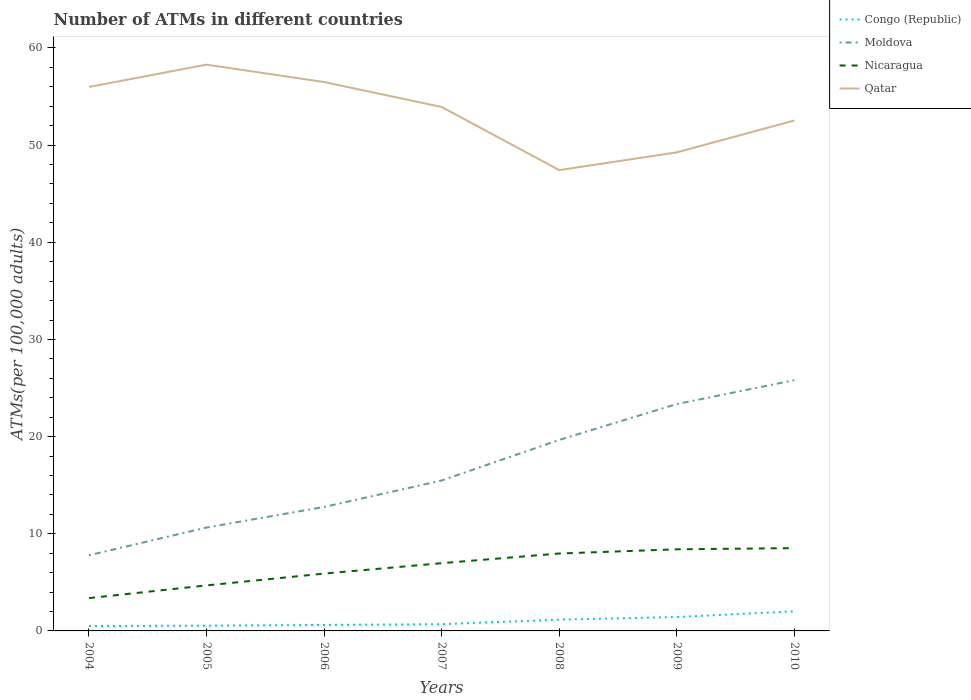How many different coloured lines are there?
Offer a very short reply. 4. Across all years, what is the maximum number of ATMs in Congo (Republic)?
Provide a short and direct response. 0.5. In which year was the number of ATMs in Nicaragua maximum?
Offer a terse response. 2004. What is the total number of ATMs in Qatar in the graph?
Your response must be concise. 5.75. What is the difference between the highest and the second highest number of ATMs in Congo (Republic)?
Give a very brief answer. 1.52. How many lines are there?
Your response must be concise. 4. How many years are there in the graph?
Your answer should be compact. 7. Does the graph contain grids?
Make the answer very short. No. Where does the legend appear in the graph?
Your response must be concise. Top right. How are the legend labels stacked?
Ensure brevity in your answer.  Vertical. What is the title of the graph?
Make the answer very short. Number of ATMs in different countries. Does "Latin America(all income levels)" appear as one of the legend labels in the graph?
Keep it short and to the point. No. What is the label or title of the Y-axis?
Your answer should be compact. ATMs(per 100,0 adults). What is the ATMs(per 100,000 adults) in Congo (Republic) in 2004?
Keep it short and to the point. 0.5. What is the ATMs(per 100,000 adults) of Moldova in 2004?
Provide a short and direct response. 7.79. What is the ATMs(per 100,000 adults) in Nicaragua in 2004?
Provide a short and direct response. 3.38. What is the ATMs(per 100,000 adults) of Qatar in 2004?
Ensure brevity in your answer.  55.99. What is the ATMs(per 100,000 adults) in Congo (Republic) in 2005?
Your response must be concise. 0.54. What is the ATMs(per 100,000 adults) of Moldova in 2005?
Your response must be concise. 10.64. What is the ATMs(per 100,000 adults) of Nicaragua in 2005?
Keep it short and to the point. 4.68. What is the ATMs(per 100,000 adults) of Qatar in 2005?
Your response must be concise. 58.28. What is the ATMs(per 100,000 adults) of Congo (Republic) in 2006?
Your answer should be very brief. 0.62. What is the ATMs(per 100,000 adults) in Moldova in 2006?
Provide a succinct answer. 12.76. What is the ATMs(per 100,000 adults) in Nicaragua in 2006?
Provide a succinct answer. 5.9. What is the ATMs(per 100,000 adults) of Qatar in 2006?
Ensure brevity in your answer.  56.49. What is the ATMs(per 100,000 adults) in Congo (Republic) in 2007?
Offer a terse response. 0.69. What is the ATMs(per 100,000 adults) of Moldova in 2007?
Keep it short and to the point. 15.48. What is the ATMs(per 100,000 adults) of Nicaragua in 2007?
Provide a succinct answer. 6.97. What is the ATMs(per 100,000 adults) of Qatar in 2007?
Give a very brief answer. 53.93. What is the ATMs(per 100,000 adults) of Congo (Republic) in 2008?
Give a very brief answer. 1.16. What is the ATMs(per 100,000 adults) in Moldova in 2008?
Your response must be concise. 19.66. What is the ATMs(per 100,000 adults) of Nicaragua in 2008?
Provide a short and direct response. 7.97. What is the ATMs(per 100,000 adults) in Qatar in 2008?
Ensure brevity in your answer.  47.43. What is the ATMs(per 100,000 adults) in Congo (Republic) in 2009?
Your response must be concise. 1.43. What is the ATMs(per 100,000 adults) in Moldova in 2009?
Your answer should be very brief. 23.35. What is the ATMs(per 100,000 adults) in Nicaragua in 2009?
Your answer should be very brief. 8.4. What is the ATMs(per 100,000 adults) in Qatar in 2009?
Your answer should be compact. 49.25. What is the ATMs(per 100,000 adults) of Congo (Republic) in 2010?
Provide a short and direct response. 2.02. What is the ATMs(per 100,000 adults) of Moldova in 2010?
Provide a short and direct response. 25.81. What is the ATMs(per 100,000 adults) of Nicaragua in 2010?
Offer a terse response. 8.52. What is the ATMs(per 100,000 adults) in Qatar in 2010?
Ensure brevity in your answer.  52.53. Across all years, what is the maximum ATMs(per 100,000 adults) in Congo (Republic)?
Keep it short and to the point. 2.02. Across all years, what is the maximum ATMs(per 100,000 adults) of Moldova?
Offer a terse response. 25.81. Across all years, what is the maximum ATMs(per 100,000 adults) in Nicaragua?
Give a very brief answer. 8.52. Across all years, what is the maximum ATMs(per 100,000 adults) of Qatar?
Provide a succinct answer. 58.28. Across all years, what is the minimum ATMs(per 100,000 adults) in Congo (Republic)?
Keep it short and to the point. 0.5. Across all years, what is the minimum ATMs(per 100,000 adults) in Moldova?
Your answer should be very brief. 7.79. Across all years, what is the minimum ATMs(per 100,000 adults) in Nicaragua?
Your response must be concise. 3.38. Across all years, what is the minimum ATMs(per 100,000 adults) in Qatar?
Keep it short and to the point. 47.43. What is the total ATMs(per 100,000 adults) of Congo (Republic) in the graph?
Offer a very short reply. 6.96. What is the total ATMs(per 100,000 adults) of Moldova in the graph?
Provide a short and direct response. 115.49. What is the total ATMs(per 100,000 adults) of Nicaragua in the graph?
Your response must be concise. 45.82. What is the total ATMs(per 100,000 adults) of Qatar in the graph?
Provide a succinct answer. 373.9. What is the difference between the ATMs(per 100,000 adults) in Congo (Republic) in 2004 and that in 2005?
Provide a short and direct response. -0.04. What is the difference between the ATMs(per 100,000 adults) in Moldova in 2004 and that in 2005?
Give a very brief answer. -2.85. What is the difference between the ATMs(per 100,000 adults) of Nicaragua in 2004 and that in 2005?
Make the answer very short. -1.31. What is the difference between the ATMs(per 100,000 adults) of Qatar in 2004 and that in 2005?
Make the answer very short. -2.3. What is the difference between the ATMs(per 100,000 adults) in Congo (Republic) in 2004 and that in 2006?
Your answer should be compact. -0.12. What is the difference between the ATMs(per 100,000 adults) of Moldova in 2004 and that in 2006?
Ensure brevity in your answer.  -4.97. What is the difference between the ATMs(per 100,000 adults) of Nicaragua in 2004 and that in 2006?
Offer a very short reply. -2.52. What is the difference between the ATMs(per 100,000 adults) in Qatar in 2004 and that in 2006?
Your answer should be compact. -0.51. What is the difference between the ATMs(per 100,000 adults) of Congo (Republic) in 2004 and that in 2007?
Offer a terse response. -0.19. What is the difference between the ATMs(per 100,000 adults) in Moldova in 2004 and that in 2007?
Offer a very short reply. -7.69. What is the difference between the ATMs(per 100,000 adults) in Nicaragua in 2004 and that in 2007?
Give a very brief answer. -3.6. What is the difference between the ATMs(per 100,000 adults) of Qatar in 2004 and that in 2007?
Offer a terse response. 2.06. What is the difference between the ATMs(per 100,000 adults) in Congo (Republic) in 2004 and that in 2008?
Your answer should be compact. -0.66. What is the difference between the ATMs(per 100,000 adults) in Moldova in 2004 and that in 2008?
Keep it short and to the point. -11.87. What is the difference between the ATMs(per 100,000 adults) in Nicaragua in 2004 and that in 2008?
Your response must be concise. -4.59. What is the difference between the ATMs(per 100,000 adults) in Qatar in 2004 and that in 2008?
Provide a short and direct response. 8.56. What is the difference between the ATMs(per 100,000 adults) in Congo (Republic) in 2004 and that in 2009?
Your response must be concise. -0.93. What is the difference between the ATMs(per 100,000 adults) in Moldova in 2004 and that in 2009?
Your answer should be compact. -15.56. What is the difference between the ATMs(per 100,000 adults) of Nicaragua in 2004 and that in 2009?
Your answer should be compact. -5.02. What is the difference between the ATMs(per 100,000 adults) of Qatar in 2004 and that in 2009?
Keep it short and to the point. 6.73. What is the difference between the ATMs(per 100,000 adults) of Congo (Republic) in 2004 and that in 2010?
Keep it short and to the point. -1.52. What is the difference between the ATMs(per 100,000 adults) of Moldova in 2004 and that in 2010?
Your response must be concise. -18.02. What is the difference between the ATMs(per 100,000 adults) in Nicaragua in 2004 and that in 2010?
Your answer should be very brief. -5.15. What is the difference between the ATMs(per 100,000 adults) in Qatar in 2004 and that in 2010?
Give a very brief answer. 3.45. What is the difference between the ATMs(per 100,000 adults) of Congo (Republic) in 2005 and that in 2006?
Offer a very short reply. -0.08. What is the difference between the ATMs(per 100,000 adults) of Moldova in 2005 and that in 2006?
Provide a short and direct response. -2.12. What is the difference between the ATMs(per 100,000 adults) of Nicaragua in 2005 and that in 2006?
Provide a succinct answer. -1.22. What is the difference between the ATMs(per 100,000 adults) of Qatar in 2005 and that in 2006?
Provide a short and direct response. 1.79. What is the difference between the ATMs(per 100,000 adults) in Congo (Republic) in 2005 and that in 2007?
Give a very brief answer. -0.15. What is the difference between the ATMs(per 100,000 adults) in Moldova in 2005 and that in 2007?
Keep it short and to the point. -4.84. What is the difference between the ATMs(per 100,000 adults) of Nicaragua in 2005 and that in 2007?
Offer a very short reply. -2.29. What is the difference between the ATMs(per 100,000 adults) of Qatar in 2005 and that in 2007?
Provide a short and direct response. 4.35. What is the difference between the ATMs(per 100,000 adults) of Congo (Republic) in 2005 and that in 2008?
Your response must be concise. -0.62. What is the difference between the ATMs(per 100,000 adults) in Moldova in 2005 and that in 2008?
Offer a very short reply. -9.02. What is the difference between the ATMs(per 100,000 adults) in Nicaragua in 2005 and that in 2008?
Provide a succinct answer. -3.28. What is the difference between the ATMs(per 100,000 adults) in Qatar in 2005 and that in 2008?
Keep it short and to the point. 10.85. What is the difference between the ATMs(per 100,000 adults) in Congo (Republic) in 2005 and that in 2009?
Give a very brief answer. -0.89. What is the difference between the ATMs(per 100,000 adults) of Moldova in 2005 and that in 2009?
Make the answer very short. -12.71. What is the difference between the ATMs(per 100,000 adults) in Nicaragua in 2005 and that in 2009?
Provide a succinct answer. -3.72. What is the difference between the ATMs(per 100,000 adults) of Qatar in 2005 and that in 2009?
Your answer should be very brief. 9.03. What is the difference between the ATMs(per 100,000 adults) in Congo (Republic) in 2005 and that in 2010?
Your answer should be compact. -1.48. What is the difference between the ATMs(per 100,000 adults) of Moldova in 2005 and that in 2010?
Your answer should be very brief. -15.17. What is the difference between the ATMs(per 100,000 adults) of Nicaragua in 2005 and that in 2010?
Ensure brevity in your answer.  -3.84. What is the difference between the ATMs(per 100,000 adults) in Qatar in 2005 and that in 2010?
Your answer should be very brief. 5.75. What is the difference between the ATMs(per 100,000 adults) in Congo (Republic) in 2006 and that in 2007?
Make the answer very short. -0.07. What is the difference between the ATMs(per 100,000 adults) of Moldova in 2006 and that in 2007?
Your answer should be very brief. -2.72. What is the difference between the ATMs(per 100,000 adults) of Nicaragua in 2006 and that in 2007?
Your answer should be very brief. -1.07. What is the difference between the ATMs(per 100,000 adults) of Qatar in 2006 and that in 2007?
Keep it short and to the point. 2.56. What is the difference between the ATMs(per 100,000 adults) in Congo (Republic) in 2006 and that in 2008?
Make the answer very short. -0.54. What is the difference between the ATMs(per 100,000 adults) in Moldova in 2006 and that in 2008?
Make the answer very short. -6.9. What is the difference between the ATMs(per 100,000 adults) of Nicaragua in 2006 and that in 2008?
Offer a very short reply. -2.07. What is the difference between the ATMs(per 100,000 adults) in Qatar in 2006 and that in 2008?
Offer a very short reply. 9.06. What is the difference between the ATMs(per 100,000 adults) of Congo (Republic) in 2006 and that in 2009?
Your answer should be very brief. -0.81. What is the difference between the ATMs(per 100,000 adults) in Moldova in 2006 and that in 2009?
Provide a short and direct response. -10.59. What is the difference between the ATMs(per 100,000 adults) in Nicaragua in 2006 and that in 2009?
Your answer should be compact. -2.5. What is the difference between the ATMs(per 100,000 adults) in Qatar in 2006 and that in 2009?
Provide a succinct answer. 7.24. What is the difference between the ATMs(per 100,000 adults) of Congo (Republic) in 2006 and that in 2010?
Ensure brevity in your answer.  -1.4. What is the difference between the ATMs(per 100,000 adults) of Moldova in 2006 and that in 2010?
Your answer should be very brief. -13.05. What is the difference between the ATMs(per 100,000 adults) in Nicaragua in 2006 and that in 2010?
Give a very brief answer. -2.62. What is the difference between the ATMs(per 100,000 adults) of Qatar in 2006 and that in 2010?
Your response must be concise. 3.96. What is the difference between the ATMs(per 100,000 adults) in Congo (Republic) in 2007 and that in 2008?
Your answer should be compact. -0.47. What is the difference between the ATMs(per 100,000 adults) in Moldova in 2007 and that in 2008?
Your response must be concise. -4.18. What is the difference between the ATMs(per 100,000 adults) in Nicaragua in 2007 and that in 2008?
Your response must be concise. -0.99. What is the difference between the ATMs(per 100,000 adults) in Qatar in 2007 and that in 2008?
Your answer should be compact. 6.5. What is the difference between the ATMs(per 100,000 adults) of Congo (Republic) in 2007 and that in 2009?
Offer a very short reply. -0.74. What is the difference between the ATMs(per 100,000 adults) in Moldova in 2007 and that in 2009?
Offer a terse response. -7.87. What is the difference between the ATMs(per 100,000 adults) of Nicaragua in 2007 and that in 2009?
Provide a succinct answer. -1.43. What is the difference between the ATMs(per 100,000 adults) of Qatar in 2007 and that in 2009?
Your answer should be compact. 4.67. What is the difference between the ATMs(per 100,000 adults) in Congo (Republic) in 2007 and that in 2010?
Keep it short and to the point. -1.33. What is the difference between the ATMs(per 100,000 adults) in Moldova in 2007 and that in 2010?
Your answer should be very brief. -10.32. What is the difference between the ATMs(per 100,000 adults) in Nicaragua in 2007 and that in 2010?
Provide a short and direct response. -1.55. What is the difference between the ATMs(per 100,000 adults) of Qatar in 2007 and that in 2010?
Ensure brevity in your answer.  1.39. What is the difference between the ATMs(per 100,000 adults) in Congo (Republic) in 2008 and that in 2009?
Your answer should be very brief. -0.27. What is the difference between the ATMs(per 100,000 adults) in Moldova in 2008 and that in 2009?
Provide a short and direct response. -3.69. What is the difference between the ATMs(per 100,000 adults) in Nicaragua in 2008 and that in 2009?
Make the answer very short. -0.43. What is the difference between the ATMs(per 100,000 adults) in Qatar in 2008 and that in 2009?
Offer a terse response. -1.82. What is the difference between the ATMs(per 100,000 adults) of Congo (Republic) in 2008 and that in 2010?
Make the answer very short. -0.86. What is the difference between the ATMs(per 100,000 adults) in Moldova in 2008 and that in 2010?
Make the answer very short. -6.15. What is the difference between the ATMs(per 100,000 adults) of Nicaragua in 2008 and that in 2010?
Keep it short and to the point. -0.56. What is the difference between the ATMs(per 100,000 adults) of Qatar in 2008 and that in 2010?
Your answer should be compact. -5.11. What is the difference between the ATMs(per 100,000 adults) of Congo (Republic) in 2009 and that in 2010?
Keep it short and to the point. -0.59. What is the difference between the ATMs(per 100,000 adults) in Moldova in 2009 and that in 2010?
Make the answer very short. -2.45. What is the difference between the ATMs(per 100,000 adults) in Nicaragua in 2009 and that in 2010?
Provide a succinct answer. -0.12. What is the difference between the ATMs(per 100,000 adults) of Qatar in 2009 and that in 2010?
Make the answer very short. -3.28. What is the difference between the ATMs(per 100,000 adults) in Congo (Republic) in 2004 and the ATMs(per 100,000 adults) in Moldova in 2005?
Make the answer very short. -10.14. What is the difference between the ATMs(per 100,000 adults) in Congo (Republic) in 2004 and the ATMs(per 100,000 adults) in Nicaragua in 2005?
Ensure brevity in your answer.  -4.18. What is the difference between the ATMs(per 100,000 adults) in Congo (Republic) in 2004 and the ATMs(per 100,000 adults) in Qatar in 2005?
Provide a succinct answer. -57.78. What is the difference between the ATMs(per 100,000 adults) in Moldova in 2004 and the ATMs(per 100,000 adults) in Nicaragua in 2005?
Give a very brief answer. 3.11. What is the difference between the ATMs(per 100,000 adults) in Moldova in 2004 and the ATMs(per 100,000 adults) in Qatar in 2005?
Provide a short and direct response. -50.49. What is the difference between the ATMs(per 100,000 adults) in Nicaragua in 2004 and the ATMs(per 100,000 adults) in Qatar in 2005?
Your response must be concise. -54.91. What is the difference between the ATMs(per 100,000 adults) of Congo (Republic) in 2004 and the ATMs(per 100,000 adults) of Moldova in 2006?
Provide a short and direct response. -12.26. What is the difference between the ATMs(per 100,000 adults) of Congo (Republic) in 2004 and the ATMs(per 100,000 adults) of Nicaragua in 2006?
Your answer should be compact. -5.4. What is the difference between the ATMs(per 100,000 adults) of Congo (Republic) in 2004 and the ATMs(per 100,000 adults) of Qatar in 2006?
Your answer should be compact. -55.99. What is the difference between the ATMs(per 100,000 adults) in Moldova in 2004 and the ATMs(per 100,000 adults) in Nicaragua in 2006?
Give a very brief answer. 1.89. What is the difference between the ATMs(per 100,000 adults) in Moldova in 2004 and the ATMs(per 100,000 adults) in Qatar in 2006?
Your answer should be very brief. -48.7. What is the difference between the ATMs(per 100,000 adults) of Nicaragua in 2004 and the ATMs(per 100,000 adults) of Qatar in 2006?
Keep it short and to the point. -53.12. What is the difference between the ATMs(per 100,000 adults) of Congo (Republic) in 2004 and the ATMs(per 100,000 adults) of Moldova in 2007?
Your response must be concise. -14.98. What is the difference between the ATMs(per 100,000 adults) in Congo (Republic) in 2004 and the ATMs(per 100,000 adults) in Nicaragua in 2007?
Your answer should be compact. -6.47. What is the difference between the ATMs(per 100,000 adults) in Congo (Republic) in 2004 and the ATMs(per 100,000 adults) in Qatar in 2007?
Your answer should be very brief. -53.43. What is the difference between the ATMs(per 100,000 adults) of Moldova in 2004 and the ATMs(per 100,000 adults) of Nicaragua in 2007?
Provide a short and direct response. 0.82. What is the difference between the ATMs(per 100,000 adults) of Moldova in 2004 and the ATMs(per 100,000 adults) of Qatar in 2007?
Make the answer very short. -46.14. What is the difference between the ATMs(per 100,000 adults) of Nicaragua in 2004 and the ATMs(per 100,000 adults) of Qatar in 2007?
Make the answer very short. -50.55. What is the difference between the ATMs(per 100,000 adults) in Congo (Republic) in 2004 and the ATMs(per 100,000 adults) in Moldova in 2008?
Ensure brevity in your answer.  -19.16. What is the difference between the ATMs(per 100,000 adults) of Congo (Republic) in 2004 and the ATMs(per 100,000 adults) of Nicaragua in 2008?
Provide a short and direct response. -7.47. What is the difference between the ATMs(per 100,000 adults) in Congo (Republic) in 2004 and the ATMs(per 100,000 adults) in Qatar in 2008?
Your answer should be very brief. -46.93. What is the difference between the ATMs(per 100,000 adults) in Moldova in 2004 and the ATMs(per 100,000 adults) in Nicaragua in 2008?
Provide a short and direct response. -0.18. What is the difference between the ATMs(per 100,000 adults) of Moldova in 2004 and the ATMs(per 100,000 adults) of Qatar in 2008?
Keep it short and to the point. -39.64. What is the difference between the ATMs(per 100,000 adults) of Nicaragua in 2004 and the ATMs(per 100,000 adults) of Qatar in 2008?
Ensure brevity in your answer.  -44.05. What is the difference between the ATMs(per 100,000 adults) of Congo (Republic) in 2004 and the ATMs(per 100,000 adults) of Moldova in 2009?
Your response must be concise. -22.85. What is the difference between the ATMs(per 100,000 adults) in Congo (Republic) in 2004 and the ATMs(per 100,000 adults) in Nicaragua in 2009?
Keep it short and to the point. -7.9. What is the difference between the ATMs(per 100,000 adults) of Congo (Republic) in 2004 and the ATMs(per 100,000 adults) of Qatar in 2009?
Provide a succinct answer. -48.75. What is the difference between the ATMs(per 100,000 adults) of Moldova in 2004 and the ATMs(per 100,000 adults) of Nicaragua in 2009?
Provide a short and direct response. -0.61. What is the difference between the ATMs(per 100,000 adults) in Moldova in 2004 and the ATMs(per 100,000 adults) in Qatar in 2009?
Your answer should be very brief. -41.46. What is the difference between the ATMs(per 100,000 adults) in Nicaragua in 2004 and the ATMs(per 100,000 adults) in Qatar in 2009?
Your answer should be compact. -45.88. What is the difference between the ATMs(per 100,000 adults) of Congo (Republic) in 2004 and the ATMs(per 100,000 adults) of Moldova in 2010?
Provide a succinct answer. -25.31. What is the difference between the ATMs(per 100,000 adults) of Congo (Republic) in 2004 and the ATMs(per 100,000 adults) of Nicaragua in 2010?
Provide a succinct answer. -8.02. What is the difference between the ATMs(per 100,000 adults) in Congo (Republic) in 2004 and the ATMs(per 100,000 adults) in Qatar in 2010?
Make the answer very short. -52.03. What is the difference between the ATMs(per 100,000 adults) in Moldova in 2004 and the ATMs(per 100,000 adults) in Nicaragua in 2010?
Give a very brief answer. -0.73. What is the difference between the ATMs(per 100,000 adults) in Moldova in 2004 and the ATMs(per 100,000 adults) in Qatar in 2010?
Provide a succinct answer. -44.75. What is the difference between the ATMs(per 100,000 adults) in Nicaragua in 2004 and the ATMs(per 100,000 adults) in Qatar in 2010?
Make the answer very short. -49.16. What is the difference between the ATMs(per 100,000 adults) of Congo (Republic) in 2005 and the ATMs(per 100,000 adults) of Moldova in 2006?
Provide a succinct answer. -12.22. What is the difference between the ATMs(per 100,000 adults) in Congo (Republic) in 2005 and the ATMs(per 100,000 adults) in Nicaragua in 2006?
Make the answer very short. -5.36. What is the difference between the ATMs(per 100,000 adults) of Congo (Republic) in 2005 and the ATMs(per 100,000 adults) of Qatar in 2006?
Give a very brief answer. -55.95. What is the difference between the ATMs(per 100,000 adults) in Moldova in 2005 and the ATMs(per 100,000 adults) in Nicaragua in 2006?
Your answer should be compact. 4.74. What is the difference between the ATMs(per 100,000 adults) in Moldova in 2005 and the ATMs(per 100,000 adults) in Qatar in 2006?
Your response must be concise. -45.85. What is the difference between the ATMs(per 100,000 adults) of Nicaragua in 2005 and the ATMs(per 100,000 adults) of Qatar in 2006?
Offer a terse response. -51.81. What is the difference between the ATMs(per 100,000 adults) in Congo (Republic) in 2005 and the ATMs(per 100,000 adults) in Moldova in 2007?
Provide a succinct answer. -14.94. What is the difference between the ATMs(per 100,000 adults) of Congo (Republic) in 2005 and the ATMs(per 100,000 adults) of Nicaragua in 2007?
Your response must be concise. -6.44. What is the difference between the ATMs(per 100,000 adults) of Congo (Republic) in 2005 and the ATMs(per 100,000 adults) of Qatar in 2007?
Offer a terse response. -53.39. What is the difference between the ATMs(per 100,000 adults) in Moldova in 2005 and the ATMs(per 100,000 adults) in Nicaragua in 2007?
Give a very brief answer. 3.67. What is the difference between the ATMs(per 100,000 adults) in Moldova in 2005 and the ATMs(per 100,000 adults) in Qatar in 2007?
Ensure brevity in your answer.  -43.29. What is the difference between the ATMs(per 100,000 adults) in Nicaragua in 2005 and the ATMs(per 100,000 adults) in Qatar in 2007?
Give a very brief answer. -49.24. What is the difference between the ATMs(per 100,000 adults) of Congo (Republic) in 2005 and the ATMs(per 100,000 adults) of Moldova in 2008?
Your answer should be compact. -19.12. What is the difference between the ATMs(per 100,000 adults) of Congo (Republic) in 2005 and the ATMs(per 100,000 adults) of Nicaragua in 2008?
Keep it short and to the point. -7.43. What is the difference between the ATMs(per 100,000 adults) of Congo (Republic) in 2005 and the ATMs(per 100,000 adults) of Qatar in 2008?
Provide a short and direct response. -46.89. What is the difference between the ATMs(per 100,000 adults) in Moldova in 2005 and the ATMs(per 100,000 adults) in Nicaragua in 2008?
Offer a very short reply. 2.67. What is the difference between the ATMs(per 100,000 adults) in Moldova in 2005 and the ATMs(per 100,000 adults) in Qatar in 2008?
Your answer should be compact. -36.79. What is the difference between the ATMs(per 100,000 adults) of Nicaragua in 2005 and the ATMs(per 100,000 adults) of Qatar in 2008?
Your answer should be compact. -42.74. What is the difference between the ATMs(per 100,000 adults) in Congo (Republic) in 2005 and the ATMs(per 100,000 adults) in Moldova in 2009?
Keep it short and to the point. -22.82. What is the difference between the ATMs(per 100,000 adults) in Congo (Republic) in 2005 and the ATMs(per 100,000 adults) in Nicaragua in 2009?
Provide a short and direct response. -7.86. What is the difference between the ATMs(per 100,000 adults) of Congo (Republic) in 2005 and the ATMs(per 100,000 adults) of Qatar in 2009?
Your response must be concise. -48.72. What is the difference between the ATMs(per 100,000 adults) of Moldova in 2005 and the ATMs(per 100,000 adults) of Nicaragua in 2009?
Make the answer very short. 2.24. What is the difference between the ATMs(per 100,000 adults) of Moldova in 2005 and the ATMs(per 100,000 adults) of Qatar in 2009?
Your response must be concise. -38.61. What is the difference between the ATMs(per 100,000 adults) in Nicaragua in 2005 and the ATMs(per 100,000 adults) in Qatar in 2009?
Make the answer very short. -44.57. What is the difference between the ATMs(per 100,000 adults) of Congo (Republic) in 2005 and the ATMs(per 100,000 adults) of Moldova in 2010?
Make the answer very short. -25.27. What is the difference between the ATMs(per 100,000 adults) in Congo (Republic) in 2005 and the ATMs(per 100,000 adults) in Nicaragua in 2010?
Provide a succinct answer. -7.99. What is the difference between the ATMs(per 100,000 adults) in Congo (Republic) in 2005 and the ATMs(per 100,000 adults) in Qatar in 2010?
Your answer should be very brief. -52. What is the difference between the ATMs(per 100,000 adults) of Moldova in 2005 and the ATMs(per 100,000 adults) of Nicaragua in 2010?
Make the answer very short. 2.12. What is the difference between the ATMs(per 100,000 adults) of Moldova in 2005 and the ATMs(per 100,000 adults) of Qatar in 2010?
Your answer should be very brief. -41.89. What is the difference between the ATMs(per 100,000 adults) in Nicaragua in 2005 and the ATMs(per 100,000 adults) in Qatar in 2010?
Your answer should be very brief. -47.85. What is the difference between the ATMs(per 100,000 adults) of Congo (Republic) in 2006 and the ATMs(per 100,000 adults) of Moldova in 2007?
Offer a terse response. -14.86. What is the difference between the ATMs(per 100,000 adults) of Congo (Republic) in 2006 and the ATMs(per 100,000 adults) of Nicaragua in 2007?
Ensure brevity in your answer.  -6.36. What is the difference between the ATMs(per 100,000 adults) in Congo (Republic) in 2006 and the ATMs(per 100,000 adults) in Qatar in 2007?
Your answer should be compact. -53.31. What is the difference between the ATMs(per 100,000 adults) in Moldova in 2006 and the ATMs(per 100,000 adults) in Nicaragua in 2007?
Provide a succinct answer. 5.79. What is the difference between the ATMs(per 100,000 adults) in Moldova in 2006 and the ATMs(per 100,000 adults) in Qatar in 2007?
Make the answer very short. -41.17. What is the difference between the ATMs(per 100,000 adults) in Nicaragua in 2006 and the ATMs(per 100,000 adults) in Qatar in 2007?
Make the answer very short. -48.03. What is the difference between the ATMs(per 100,000 adults) in Congo (Republic) in 2006 and the ATMs(per 100,000 adults) in Moldova in 2008?
Provide a succinct answer. -19.04. What is the difference between the ATMs(per 100,000 adults) in Congo (Republic) in 2006 and the ATMs(per 100,000 adults) in Nicaragua in 2008?
Your response must be concise. -7.35. What is the difference between the ATMs(per 100,000 adults) in Congo (Republic) in 2006 and the ATMs(per 100,000 adults) in Qatar in 2008?
Ensure brevity in your answer.  -46.81. What is the difference between the ATMs(per 100,000 adults) of Moldova in 2006 and the ATMs(per 100,000 adults) of Nicaragua in 2008?
Offer a very short reply. 4.79. What is the difference between the ATMs(per 100,000 adults) in Moldova in 2006 and the ATMs(per 100,000 adults) in Qatar in 2008?
Keep it short and to the point. -34.67. What is the difference between the ATMs(per 100,000 adults) in Nicaragua in 2006 and the ATMs(per 100,000 adults) in Qatar in 2008?
Keep it short and to the point. -41.53. What is the difference between the ATMs(per 100,000 adults) of Congo (Republic) in 2006 and the ATMs(per 100,000 adults) of Moldova in 2009?
Offer a terse response. -22.74. What is the difference between the ATMs(per 100,000 adults) in Congo (Republic) in 2006 and the ATMs(per 100,000 adults) in Nicaragua in 2009?
Give a very brief answer. -7.78. What is the difference between the ATMs(per 100,000 adults) in Congo (Republic) in 2006 and the ATMs(per 100,000 adults) in Qatar in 2009?
Give a very brief answer. -48.64. What is the difference between the ATMs(per 100,000 adults) in Moldova in 2006 and the ATMs(per 100,000 adults) in Nicaragua in 2009?
Offer a very short reply. 4.36. What is the difference between the ATMs(per 100,000 adults) in Moldova in 2006 and the ATMs(per 100,000 adults) in Qatar in 2009?
Your answer should be very brief. -36.49. What is the difference between the ATMs(per 100,000 adults) of Nicaragua in 2006 and the ATMs(per 100,000 adults) of Qatar in 2009?
Ensure brevity in your answer.  -43.35. What is the difference between the ATMs(per 100,000 adults) in Congo (Republic) in 2006 and the ATMs(per 100,000 adults) in Moldova in 2010?
Your response must be concise. -25.19. What is the difference between the ATMs(per 100,000 adults) of Congo (Republic) in 2006 and the ATMs(per 100,000 adults) of Nicaragua in 2010?
Provide a short and direct response. -7.91. What is the difference between the ATMs(per 100,000 adults) in Congo (Republic) in 2006 and the ATMs(per 100,000 adults) in Qatar in 2010?
Provide a succinct answer. -51.92. What is the difference between the ATMs(per 100,000 adults) of Moldova in 2006 and the ATMs(per 100,000 adults) of Nicaragua in 2010?
Offer a very short reply. 4.24. What is the difference between the ATMs(per 100,000 adults) of Moldova in 2006 and the ATMs(per 100,000 adults) of Qatar in 2010?
Offer a terse response. -39.78. What is the difference between the ATMs(per 100,000 adults) in Nicaragua in 2006 and the ATMs(per 100,000 adults) in Qatar in 2010?
Keep it short and to the point. -46.63. What is the difference between the ATMs(per 100,000 adults) of Congo (Republic) in 2007 and the ATMs(per 100,000 adults) of Moldova in 2008?
Offer a terse response. -18.97. What is the difference between the ATMs(per 100,000 adults) in Congo (Republic) in 2007 and the ATMs(per 100,000 adults) in Nicaragua in 2008?
Offer a terse response. -7.28. What is the difference between the ATMs(per 100,000 adults) of Congo (Republic) in 2007 and the ATMs(per 100,000 adults) of Qatar in 2008?
Ensure brevity in your answer.  -46.74. What is the difference between the ATMs(per 100,000 adults) in Moldova in 2007 and the ATMs(per 100,000 adults) in Nicaragua in 2008?
Make the answer very short. 7.52. What is the difference between the ATMs(per 100,000 adults) of Moldova in 2007 and the ATMs(per 100,000 adults) of Qatar in 2008?
Your response must be concise. -31.95. What is the difference between the ATMs(per 100,000 adults) in Nicaragua in 2007 and the ATMs(per 100,000 adults) in Qatar in 2008?
Offer a terse response. -40.46. What is the difference between the ATMs(per 100,000 adults) in Congo (Republic) in 2007 and the ATMs(per 100,000 adults) in Moldova in 2009?
Ensure brevity in your answer.  -22.66. What is the difference between the ATMs(per 100,000 adults) of Congo (Republic) in 2007 and the ATMs(per 100,000 adults) of Nicaragua in 2009?
Provide a short and direct response. -7.71. What is the difference between the ATMs(per 100,000 adults) in Congo (Republic) in 2007 and the ATMs(per 100,000 adults) in Qatar in 2009?
Give a very brief answer. -48.56. What is the difference between the ATMs(per 100,000 adults) of Moldova in 2007 and the ATMs(per 100,000 adults) of Nicaragua in 2009?
Offer a very short reply. 7.08. What is the difference between the ATMs(per 100,000 adults) of Moldova in 2007 and the ATMs(per 100,000 adults) of Qatar in 2009?
Your answer should be compact. -33.77. What is the difference between the ATMs(per 100,000 adults) of Nicaragua in 2007 and the ATMs(per 100,000 adults) of Qatar in 2009?
Give a very brief answer. -42.28. What is the difference between the ATMs(per 100,000 adults) of Congo (Republic) in 2007 and the ATMs(per 100,000 adults) of Moldova in 2010?
Provide a succinct answer. -25.12. What is the difference between the ATMs(per 100,000 adults) in Congo (Republic) in 2007 and the ATMs(per 100,000 adults) in Nicaragua in 2010?
Your answer should be compact. -7.83. What is the difference between the ATMs(per 100,000 adults) in Congo (Republic) in 2007 and the ATMs(per 100,000 adults) in Qatar in 2010?
Ensure brevity in your answer.  -51.84. What is the difference between the ATMs(per 100,000 adults) in Moldova in 2007 and the ATMs(per 100,000 adults) in Nicaragua in 2010?
Give a very brief answer. 6.96. What is the difference between the ATMs(per 100,000 adults) of Moldova in 2007 and the ATMs(per 100,000 adults) of Qatar in 2010?
Give a very brief answer. -37.05. What is the difference between the ATMs(per 100,000 adults) in Nicaragua in 2007 and the ATMs(per 100,000 adults) in Qatar in 2010?
Your response must be concise. -45.56. What is the difference between the ATMs(per 100,000 adults) in Congo (Republic) in 2008 and the ATMs(per 100,000 adults) in Moldova in 2009?
Offer a terse response. -22.19. What is the difference between the ATMs(per 100,000 adults) of Congo (Republic) in 2008 and the ATMs(per 100,000 adults) of Nicaragua in 2009?
Make the answer very short. -7.24. What is the difference between the ATMs(per 100,000 adults) in Congo (Republic) in 2008 and the ATMs(per 100,000 adults) in Qatar in 2009?
Your response must be concise. -48.09. What is the difference between the ATMs(per 100,000 adults) of Moldova in 2008 and the ATMs(per 100,000 adults) of Nicaragua in 2009?
Provide a short and direct response. 11.26. What is the difference between the ATMs(per 100,000 adults) of Moldova in 2008 and the ATMs(per 100,000 adults) of Qatar in 2009?
Keep it short and to the point. -29.6. What is the difference between the ATMs(per 100,000 adults) of Nicaragua in 2008 and the ATMs(per 100,000 adults) of Qatar in 2009?
Your answer should be compact. -41.29. What is the difference between the ATMs(per 100,000 adults) of Congo (Republic) in 2008 and the ATMs(per 100,000 adults) of Moldova in 2010?
Offer a very short reply. -24.65. What is the difference between the ATMs(per 100,000 adults) of Congo (Republic) in 2008 and the ATMs(per 100,000 adults) of Nicaragua in 2010?
Your answer should be very brief. -7.36. What is the difference between the ATMs(per 100,000 adults) of Congo (Republic) in 2008 and the ATMs(per 100,000 adults) of Qatar in 2010?
Give a very brief answer. -51.37. What is the difference between the ATMs(per 100,000 adults) of Moldova in 2008 and the ATMs(per 100,000 adults) of Nicaragua in 2010?
Give a very brief answer. 11.13. What is the difference between the ATMs(per 100,000 adults) of Moldova in 2008 and the ATMs(per 100,000 adults) of Qatar in 2010?
Offer a very short reply. -32.88. What is the difference between the ATMs(per 100,000 adults) of Nicaragua in 2008 and the ATMs(per 100,000 adults) of Qatar in 2010?
Ensure brevity in your answer.  -44.57. What is the difference between the ATMs(per 100,000 adults) of Congo (Republic) in 2009 and the ATMs(per 100,000 adults) of Moldova in 2010?
Offer a terse response. -24.38. What is the difference between the ATMs(per 100,000 adults) of Congo (Republic) in 2009 and the ATMs(per 100,000 adults) of Nicaragua in 2010?
Your answer should be very brief. -7.09. What is the difference between the ATMs(per 100,000 adults) of Congo (Republic) in 2009 and the ATMs(per 100,000 adults) of Qatar in 2010?
Provide a short and direct response. -51.11. What is the difference between the ATMs(per 100,000 adults) in Moldova in 2009 and the ATMs(per 100,000 adults) in Nicaragua in 2010?
Offer a very short reply. 14.83. What is the difference between the ATMs(per 100,000 adults) of Moldova in 2009 and the ATMs(per 100,000 adults) of Qatar in 2010?
Provide a succinct answer. -29.18. What is the difference between the ATMs(per 100,000 adults) of Nicaragua in 2009 and the ATMs(per 100,000 adults) of Qatar in 2010?
Make the answer very short. -44.13. What is the average ATMs(per 100,000 adults) of Moldova per year?
Provide a short and direct response. 16.5. What is the average ATMs(per 100,000 adults) in Nicaragua per year?
Your answer should be compact. 6.55. What is the average ATMs(per 100,000 adults) of Qatar per year?
Offer a terse response. 53.41. In the year 2004, what is the difference between the ATMs(per 100,000 adults) in Congo (Republic) and ATMs(per 100,000 adults) in Moldova?
Your answer should be compact. -7.29. In the year 2004, what is the difference between the ATMs(per 100,000 adults) of Congo (Republic) and ATMs(per 100,000 adults) of Nicaragua?
Your answer should be very brief. -2.88. In the year 2004, what is the difference between the ATMs(per 100,000 adults) of Congo (Republic) and ATMs(per 100,000 adults) of Qatar?
Make the answer very short. -55.48. In the year 2004, what is the difference between the ATMs(per 100,000 adults) of Moldova and ATMs(per 100,000 adults) of Nicaragua?
Your answer should be compact. 4.41. In the year 2004, what is the difference between the ATMs(per 100,000 adults) in Moldova and ATMs(per 100,000 adults) in Qatar?
Make the answer very short. -48.2. In the year 2004, what is the difference between the ATMs(per 100,000 adults) in Nicaragua and ATMs(per 100,000 adults) in Qatar?
Give a very brief answer. -52.61. In the year 2005, what is the difference between the ATMs(per 100,000 adults) in Congo (Republic) and ATMs(per 100,000 adults) in Moldova?
Give a very brief answer. -10.1. In the year 2005, what is the difference between the ATMs(per 100,000 adults) of Congo (Republic) and ATMs(per 100,000 adults) of Nicaragua?
Provide a succinct answer. -4.15. In the year 2005, what is the difference between the ATMs(per 100,000 adults) of Congo (Republic) and ATMs(per 100,000 adults) of Qatar?
Provide a succinct answer. -57.75. In the year 2005, what is the difference between the ATMs(per 100,000 adults) of Moldova and ATMs(per 100,000 adults) of Nicaragua?
Make the answer very short. 5.96. In the year 2005, what is the difference between the ATMs(per 100,000 adults) in Moldova and ATMs(per 100,000 adults) in Qatar?
Keep it short and to the point. -47.64. In the year 2005, what is the difference between the ATMs(per 100,000 adults) of Nicaragua and ATMs(per 100,000 adults) of Qatar?
Give a very brief answer. -53.6. In the year 2006, what is the difference between the ATMs(per 100,000 adults) of Congo (Republic) and ATMs(per 100,000 adults) of Moldova?
Offer a very short reply. -12.14. In the year 2006, what is the difference between the ATMs(per 100,000 adults) in Congo (Republic) and ATMs(per 100,000 adults) in Nicaragua?
Ensure brevity in your answer.  -5.28. In the year 2006, what is the difference between the ATMs(per 100,000 adults) of Congo (Republic) and ATMs(per 100,000 adults) of Qatar?
Your response must be concise. -55.88. In the year 2006, what is the difference between the ATMs(per 100,000 adults) in Moldova and ATMs(per 100,000 adults) in Nicaragua?
Your response must be concise. 6.86. In the year 2006, what is the difference between the ATMs(per 100,000 adults) of Moldova and ATMs(per 100,000 adults) of Qatar?
Keep it short and to the point. -43.73. In the year 2006, what is the difference between the ATMs(per 100,000 adults) of Nicaragua and ATMs(per 100,000 adults) of Qatar?
Your answer should be very brief. -50.59. In the year 2007, what is the difference between the ATMs(per 100,000 adults) of Congo (Republic) and ATMs(per 100,000 adults) of Moldova?
Your answer should be very brief. -14.79. In the year 2007, what is the difference between the ATMs(per 100,000 adults) of Congo (Republic) and ATMs(per 100,000 adults) of Nicaragua?
Give a very brief answer. -6.28. In the year 2007, what is the difference between the ATMs(per 100,000 adults) of Congo (Republic) and ATMs(per 100,000 adults) of Qatar?
Provide a short and direct response. -53.24. In the year 2007, what is the difference between the ATMs(per 100,000 adults) of Moldova and ATMs(per 100,000 adults) of Nicaragua?
Provide a short and direct response. 8.51. In the year 2007, what is the difference between the ATMs(per 100,000 adults) in Moldova and ATMs(per 100,000 adults) in Qatar?
Provide a short and direct response. -38.45. In the year 2007, what is the difference between the ATMs(per 100,000 adults) of Nicaragua and ATMs(per 100,000 adults) of Qatar?
Offer a very short reply. -46.95. In the year 2008, what is the difference between the ATMs(per 100,000 adults) in Congo (Republic) and ATMs(per 100,000 adults) in Moldova?
Your answer should be very brief. -18.5. In the year 2008, what is the difference between the ATMs(per 100,000 adults) in Congo (Republic) and ATMs(per 100,000 adults) in Nicaragua?
Keep it short and to the point. -6.81. In the year 2008, what is the difference between the ATMs(per 100,000 adults) of Congo (Republic) and ATMs(per 100,000 adults) of Qatar?
Your answer should be very brief. -46.27. In the year 2008, what is the difference between the ATMs(per 100,000 adults) in Moldova and ATMs(per 100,000 adults) in Nicaragua?
Your answer should be very brief. 11.69. In the year 2008, what is the difference between the ATMs(per 100,000 adults) in Moldova and ATMs(per 100,000 adults) in Qatar?
Your answer should be very brief. -27.77. In the year 2008, what is the difference between the ATMs(per 100,000 adults) of Nicaragua and ATMs(per 100,000 adults) of Qatar?
Your response must be concise. -39.46. In the year 2009, what is the difference between the ATMs(per 100,000 adults) of Congo (Republic) and ATMs(per 100,000 adults) of Moldova?
Your answer should be very brief. -21.92. In the year 2009, what is the difference between the ATMs(per 100,000 adults) of Congo (Republic) and ATMs(per 100,000 adults) of Nicaragua?
Provide a succinct answer. -6.97. In the year 2009, what is the difference between the ATMs(per 100,000 adults) of Congo (Republic) and ATMs(per 100,000 adults) of Qatar?
Give a very brief answer. -47.82. In the year 2009, what is the difference between the ATMs(per 100,000 adults) of Moldova and ATMs(per 100,000 adults) of Nicaragua?
Offer a terse response. 14.95. In the year 2009, what is the difference between the ATMs(per 100,000 adults) in Moldova and ATMs(per 100,000 adults) in Qatar?
Ensure brevity in your answer.  -25.9. In the year 2009, what is the difference between the ATMs(per 100,000 adults) of Nicaragua and ATMs(per 100,000 adults) of Qatar?
Keep it short and to the point. -40.85. In the year 2010, what is the difference between the ATMs(per 100,000 adults) in Congo (Republic) and ATMs(per 100,000 adults) in Moldova?
Your response must be concise. -23.79. In the year 2010, what is the difference between the ATMs(per 100,000 adults) in Congo (Republic) and ATMs(per 100,000 adults) in Nicaragua?
Your answer should be compact. -6.5. In the year 2010, what is the difference between the ATMs(per 100,000 adults) of Congo (Republic) and ATMs(per 100,000 adults) of Qatar?
Your response must be concise. -50.51. In the year 2010, what is the difference between the ATMs(per 100,000 adults) of Moldova and ATMs(per 100,000 adults) of Nicaragua?
Ensure brevity in your answer.  17.28. In the year 2010, what is the difference between the ATMs(per 100,000 adults) in Moldova and ATMs(per 100,000 adults) in Qatar?
Give a very brief answer. -26.73. In the year 2010, what is the difference between the ATMs(per 100,000 adults) in Nicaragua and ATMs(per 100,000 adults) in Qatar?
Offer a terse response. -44.01. What is the ratio of the ATMs(per 100,000 adults) in Congo (Republic) in 2004 to that in 2005?
Offer a terse response. 0.93. What is the ratio of the ATMs(per 100,000 adults) in Moldova in 2004 to that in 2005?
Give a very brief answer. 0.73. What is the ratio of the ATMs(per 100,000 adults) in Nicaragua in 2004 to that in 2005?
Provide a succinct answer. 0.72. What is the ratio of the ATMs(per 100,000 adults) in Qatar in 2004 to that in 2005?
Offer a terse response. 0.96. What is the ratio of the ATMs(per 100,000 adults) in Congo (Republic) in 2004 to that in 2006?
Offer a terse response. 0.81. What is the ratio of the ATMs(per 100,000 adults) of Moldova in 2004 to that in 2006?
Your answer should be compact. 0.61. What is the ratio of the ATMs(per 100,000 adults) in Nicaragua in 2004 to that in 2006?
Your response must be concise. 0.57. What is the ratio of the ATMs(per 100,000 adults) of Congo (Republic) in 2004 to that in 2007?
Your response must be concise. 0.73. What is the ratio of the ATMs(per 100,000 adults) of Moldova in 2004 to that in 2007?
Your answer should be very brief. 0.5. What is the ratio of the ATMs(per 100,000 adults) of Nicaragua in 2004 to that in 2007?
Provide a short and direct response. 0.48. What is the ratio of the ATMs(per 100,000 adults) in Qatar in 2004 to that in 2007?
Provide a short and direct response. 1.04. What is the ratio of the ATMs(per 100,000 adults) in Congo (Republic) in 2004 to that in 2008?
Keep it short and to the point. 0.43. What is the ratio of the ATMs(per 100,000 adults) of Moldova in 2004 to that in 2008?
Your response must be concise. 0.4. What is the ratio of the ATMs(per 100,000 adults) in Nicaragua in 2004 to that in 2008?
Provide a succinct answer. 0.42. What is the ratio of the ATMs(per 100,000 adults) in Qatar in 2004 to that in 2008?
Give a very brief answer. 1.18. What is the ratio of the ATMs(per 100,000 adults) of Congo (Republic) in 2004 to that in 2009?
Keep it short and to the point. 0.35. What is the ratio of the ATMs(per 100,000 adults) in Moldova in 2004 to that in 2009?
Provide a short and direct response. 0.33. What is the ratio of the ATMs(per 100,000 adults) in Nicaragua in 2004 to that in 2009?
Make the answer very short. 0.4. What is the ratio of the ATMs(per 100,000 adults) in Qatar in 2004 to that in 2009?
Your answer should be compact. 1.14. What is the ratio of the ATMs(per 100,000 adults) of Congo (Republic) in 2004 to that in 2010?
Your answer should be very brief. 0.25. What is the ratio of the ATMs(per 100,000 adults) in Moldova in 2004 to that in 2010?
Offer a very short reply. 0.3. What is the ratio of the ATMs(per 100,000 adults) of Nicaragua in 2004 to that in 2010?
Offer a terse response. 0.4. What is the ratio of the ATMs(per 100,000 adults) of Qatar in 2004 to that in 2010?
Offer a very short reply. 1.07. What is the ratio of the ATMs(per 100,000 adults) of Congo (Republic) in 2005 to that in 2006?
Provide a short and direct response. 0.87. What is the ratio of the ATMs(per 100,000 adults) in Moldova in 2005 to that in 2006?
Provide a short and direct response. 0.83. What is the ratio of the ATMs(per 100,000 adults) of Nicaragua in 2005 to that in 2006?
Your answer should be compact. 0.79. What is the ratio of the ATMs(per 100,000 adults) of Qatar in 2005 to that in 2006?
Provide a short and direct response. 1.03. What is the ratio of the ATMs(per 100,000 adults) of Congo (Republic) in 2005 to that in 2007?
Provide a short and direct response. 0.78. What is the ratio of the ATMs(per 100,000 adults) in Moldova in 2005 to that in 2007?
Offer a terse response. 0.69. What is the ratio of the ATMs(per 100,000 adults) in Nicaragua in 2005 to that in 2007?
Give a very brief answer. 0.67. What is the ratio of the ATMs(per 100,000 adults) of Qatar in 2005 to that in 2007?
Make the answer very short. 1.08. What is the ratio of the ATMs(per 100,000 adults) in Congo (Republic) in 2005 to that in 2008?
Make the answer very short. 0.46. What is the ratio of the ATMs(per 100,000 adults) of Moldova in 2005 to that in 2008?
Your answer should be compact. 0.54. What is the ratio of the ATMs(per 100,000 adults) in Nicaragua in 2005 to that in 2008?
Offer a very short reply. 0.59. What is the ratio of the ATMs(per 100,000 adults) of Qatar in 2005 to that in 2008?
Your answer should be very brief. 1.23. What is the ratio of the ATMs(per 100,000 adults) in Congo (Republic) in 2005 to that in 2009?
Make the answer very short. 0.38. What is the ratio of the ATMs(per 100,000 adults) in Moldova in 2005 to that in 2009?
Your response must be concise. 0.46. What is the ratio of the ATMs(per 100,000 adults) of Nicaragua in 2005 to that in 2009?
Ensure brevity in your answer.  0.56. What is the ratio of the ATMs(per 100,000 adults) of Qatar in 2005 to that in 2009?
Keep it short and to the point. 1.18. What is the ratio of the ATMs(per 100,000 adults) in Congo (Republic) in 2005 to that in 2010?
Ensure brevity in your answer.  0.27. What is the ratio of the ATMs(per 100,000 adults) in Moldova in 2005 to that in 2010?
Offer a terse response. 0.41. What is the ratio of the ATMs(per 100,000 adults) of Nicaragua in 2005 to that in 2010?
Offer a very short reply. 0.55. What is the ratio of the ATMs(per 100,000 adults) of Qatar in 2005 to that in 2010?
Make the answer very short. 1.11. What is the ratio of the ATMs(per 100,000 adults) of Congo (Republic) in 2006 to that in 2007?
Make the answer very short. 0.89. What is the ratio of the ATMs(per 100,000 adults) of Moldova in 2006 to that in 2007?
Make the answer very short. 0.82. What is the ratio of the ATMs(per 100,000 adults) in Nicaragua in 2006 to that in 2007?
Your response must be concise. 0.85. What is the ratio of the ATMs(per 100,000 adults) in Qatar in 2006 to that in 2007?
Offer a very short reply. 1.05. What is the ratio of the ATMs(per 100,000 adults) of Congo (Republic) in 2006 to that in 2008?
Keep it short and to the point. 0.53. What is the ratio of the ATMs(per 100,000 adults) of Moldova in 2006 to that in 2008?
Offer a terse response. 0.65. What is the ratio of the ATMs(per 100,000 adults) in Nicaragua in 2006 to that in 2008?
Offer a terse response. 0.74. What is the ratio of the ATMs(per 100,000 adults) of Qatar in 2006 to that in 2008?
Offer a very short reply. 1.19. What is the ratio of the ATMs(per 100,000 adults) in Congo (Republic) in 2006 to that in 2009?
Offer a very short reply. 0.43. What is the ratio of the ATMs(per 100,000 adults) in Moldova in 2006 to that in 2009?
Your answer should be very brief. 0.55. What is the ratio of the ATMs(per 100,000 adults) of Nicaragua in 2006 to that in 2009?
Your answer should be compact. 0.7. What is the ratio of the ATMs(per 100,000 adults) in Qatar in 2006 to that in 2009?
Offer a terse response. 1.15. What is the ratio of the ATMs(per 100,000 adults) of Congo (Republic) in 2006 to that in 2010?
Provide a succinct answer. 0.31. What is the ratio of the ATMs(per 100,000 adults) of Moldova in 2006 to that in 2010?
Offer a terse response. 0.49. What is the ratio of the ATMs(per 100,000 adults) in Nicaragua in 2006 to that in 2010?
Offer a terse response. 0.69. What is the ratio of the ATMs(per 100,000 adults) in Qatar in 2006 to that in 2010?
Provide a succinct answer. 1.08. What is the ratio of the ATMs(per 100,000 adults) in Congo (Republic) in 2007 to that in 2008?
Your answer should be compact. 0.6. What is the ratio of the ATMs(per 100,000 adults) of Moldova in 2007 to that in 2008?
Offer a very short reply. 0.79. What is the ratio of the ATMs(per 100,000 adults) of Nicaragua in 2007 to that in 2008?
Keep it short and to the point. 0.88. What is the ratio of the ATMs(per 100,000 adults) of Qatar in 2007 to that in 2008?
Your response must be concise. 1.14. What is the ratio of the ATMs(per 100,000 adults) in Congo (Republic) in 2007 to that in 2009?
Provide a short and direct response. 0.48. What is the ratio of the ATMs(per 100,000 adults) in Moldova in 2007 to that in 2009?
Keep it short and to the point. 0.66. What is the ratio of the ATMs(per 100,000 adults) in Nicaragua in 2007 to that in 2009?
Offer a very short reply. 0.83. What is the ratio of the ATMs(per 100,000 adults) in Qatar in 2007 to that in 2009?
Provide a succinct answer. 1.09. What is the ratio of the ATMs(per 100,000 adults) in Congo (Republic) in 2007 to that in 2010?
Keep it short and to the point. 0.34. What is the ratio of the ATMs(per 100,000 adults) in Moldova in 2007 to that in 2010?
Make the answer very short. 0.6. What is the ratio of the ATMs(per 100,000 adults) of Nicaragua in 2007 to that in 2010?
Provide a succinct answer. 0.82. What is the ratio of the ATMs(per 100,000 adults) in Qatar in 2007 to that in 2010?
Provide a succinct answer. 1.03. What is the ratio of the ATMs(per 100,000 adults) of Congo (Republic) in 2008 to that in 2009?
Your answer should be very brief. 0.81. What is the ratio of the ATMs(per 100,000 adults) of Moldova in 2008 to that in 2009?
Your answer should be compact. 0.84. What is the ratio of the ATMs(per 100,000 adults) in Nicaragua in 2008 to that in 2009?
Ensure brevity in your answer.  0.95. What is the ratio of the ATMs(per 100,000 adults) of Congo (Republic) in 2008 to that in 2010?
Give a very brief answer. 0.57. What is the ratio of the ATMs(per 100,000 adults) in Moldova in 2008 to that in 2010?
Give a very brief answer. 0.76. What is the ratio of the ATMs(per 100,000 adults) of Nicaragua in 2008 to that in 2010?
Your response must be concise. 0.93. What is the ratio of the ATMs(per 100,000 adults) of Qatar in 2008 to that in 2010?
Your response must be concise. 0.9. What is the ratio of the ATMs(per 100,000 adults) in Congo (Republic) in 2009 to that in 2010?
Offer a very short reply. 0.71. What is the ratio of the ATMs(per 100,000 adults) of Moldova in 2009 to that in 2010?
Your response must be concise. 0.9. What is the ratio of the ATMs(per 100,000 adults) in Nicaragua in 2009 to that in 2010?
Your answer should be compact. 0.99. What is the difference between the highest and the second highest ATMs(per 100,000 adults) in Congo (Republic)?
Your answer should be compact. 0.59. What is the difference between the highest and the second highest ATMs(per 100,000 adults) of Moldova?
Provide a succinct answer. 2.45. What is the difference between the highest and the second highest ATMs(per 100,000 adults) of Nicaragua?
Keep it short and to the point. 0.12. What is the difference between the highest and the second highest ATMs(per 100,000 adults) of Qatar?
Your answer should be very brief. 1.79. What is the difference between the highest and the lowest ATMs(per 100,000 adults) of Congo (Republic)?
Make the answer very short. 1.52. What is the difference between the highest and the lowest ATMs(per 100,000 adults) of Moldova?
Your answer should be very brief. 18.02. What is the difference between the highest and the lowest ATMs(per 100,000 adults) of Nicaragua?
Your answer should be very brief. 5.15. What is the difference between the highest and the lowest ATMs(per 100,000 adults) in Qatar?
Offer a very short reply. 10.85. 